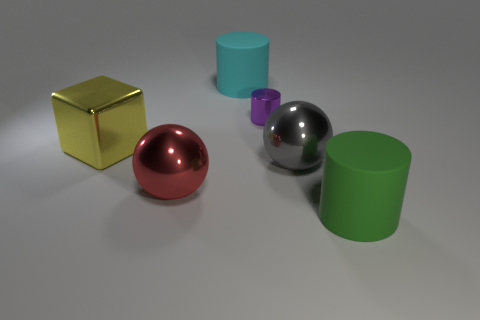The purple thing is what size?
Make the answer very short. Small. Is the large cylinder in front of the red metal ball made of the same material as the big yellow thing?
Your answer should be very brief. No. Do the tiny purple shiny object and the cyan object have the same shape?
Keep it short and to the point. Yes. The large matte thing behind the big cylinder that is right of the matte cylinder that is behind the purple metallic cylinder is what shape?
Provide a short and direct response. Cylinder. There is a matte thing that is behind the purple metallic cylinder; is its shape the same as the shiny thing to the right of the purple metallic object?
Your response must be concise. No. Is there a large red ball made of the same material as the cyan cylinder?
Your response must be concise. No. There is a big shiny sphere right of the rubber cylinder left of the large thing to the right of the big gray metal sphere; what color is it?
Keep it short and to the point. Gray. Do the large cylinder that is behind the green rubber object and the ball right of the purple thing have the same material?
Offer a very short reply. No. There is a big matte object that is right of the big gray object; what is its shape?
Keep it short and to the point. Cylinder. How many things are purple matte cubes or objects on the left side of the small purple cylinder?
Your response must be concise. 3. 